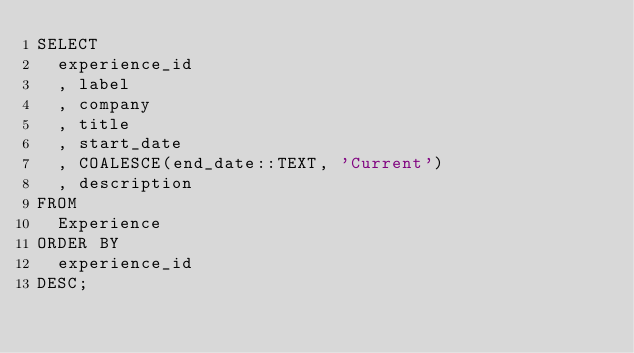Convert code to text. <code><loc_0><loc_0><loc_500><loc_500><_SQL_>SELECT
  experience_id
  , label
  , company
  , title
  , start_date
  , COALESCE(end_date::TEXT, 'Current')
  , description
FROM
  Experience
ORDER BY
  experience_id
DESC;
</code> 